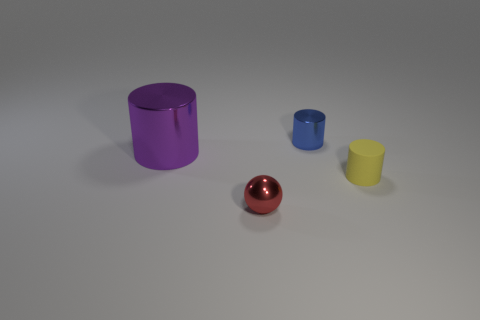Are there an equal number of red metallic things in front of the purple cylinder and small blue objects in front of the blue shiny cylinder?
Provide a succinct answer. No. Does the blue metallic thing behind the tiny red sphere have the same size as the shiny cylinder left of the ball?
Offer a very short reply. No. What is the material of the tiny thing that is both behind the red metal ball and on the left side of the yellow matte object?
Your answer should be very brief. Metal. Are there fewer red metallic balls than rubber balls?
Make the answer very short. No. What is the size of the thing that is right of the small shiny object behind the shiny ball?
Make the answer very short. Small. What is the shape of the metallic object that is on the right side of the metallic thing that is in front of the shiny object that is left of the red sphere?
Your answer should be compact. Cylinder. There is a small ball that is made of the same material as the purple thing; what color is it?
Offer a terse response. Red. There is a tiny cylinder behind the object that is to the left of the thing in front of the rubber cylinder; what is its color?
Offer a terse response. Blue. How many spheres are tiny red metal objects or yellow objects?
Provide a short and direct response. 1. There is a large shiny cylinder; is it the same color as the cylinder in front of the large purple metal cylinder?
Offer a very short reply. No. 